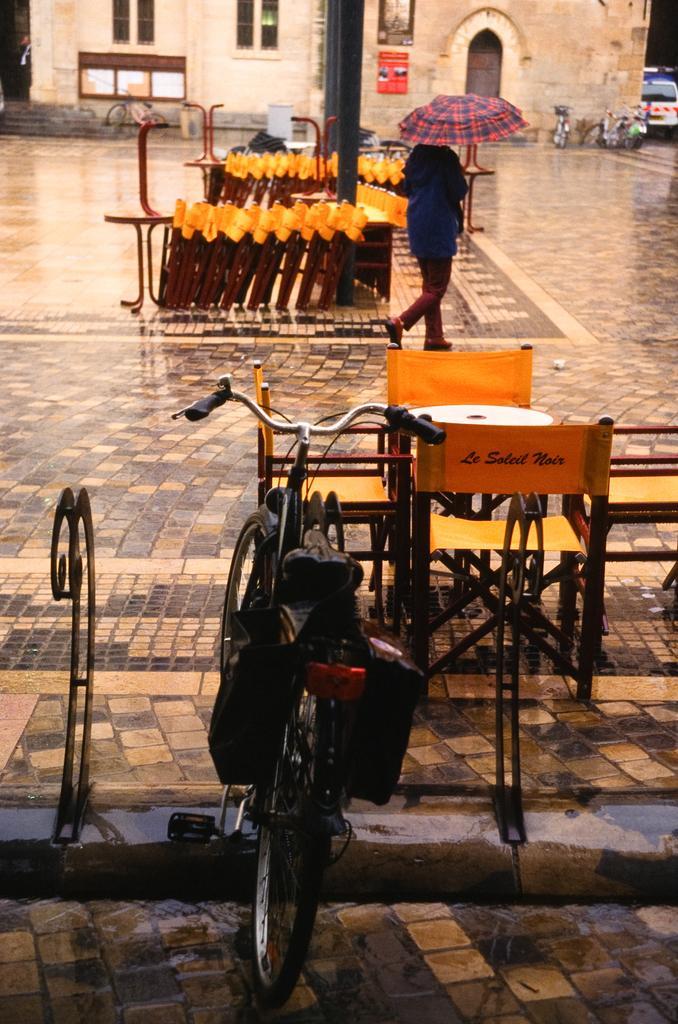Please provide a concise description of this image. In this image we have a person who is walking on the street by holding an umbrella in his hand. In the front of the image we have bicycle and a few chairs and a table on the street. On the right corner of the image we have a vehicle and building. 